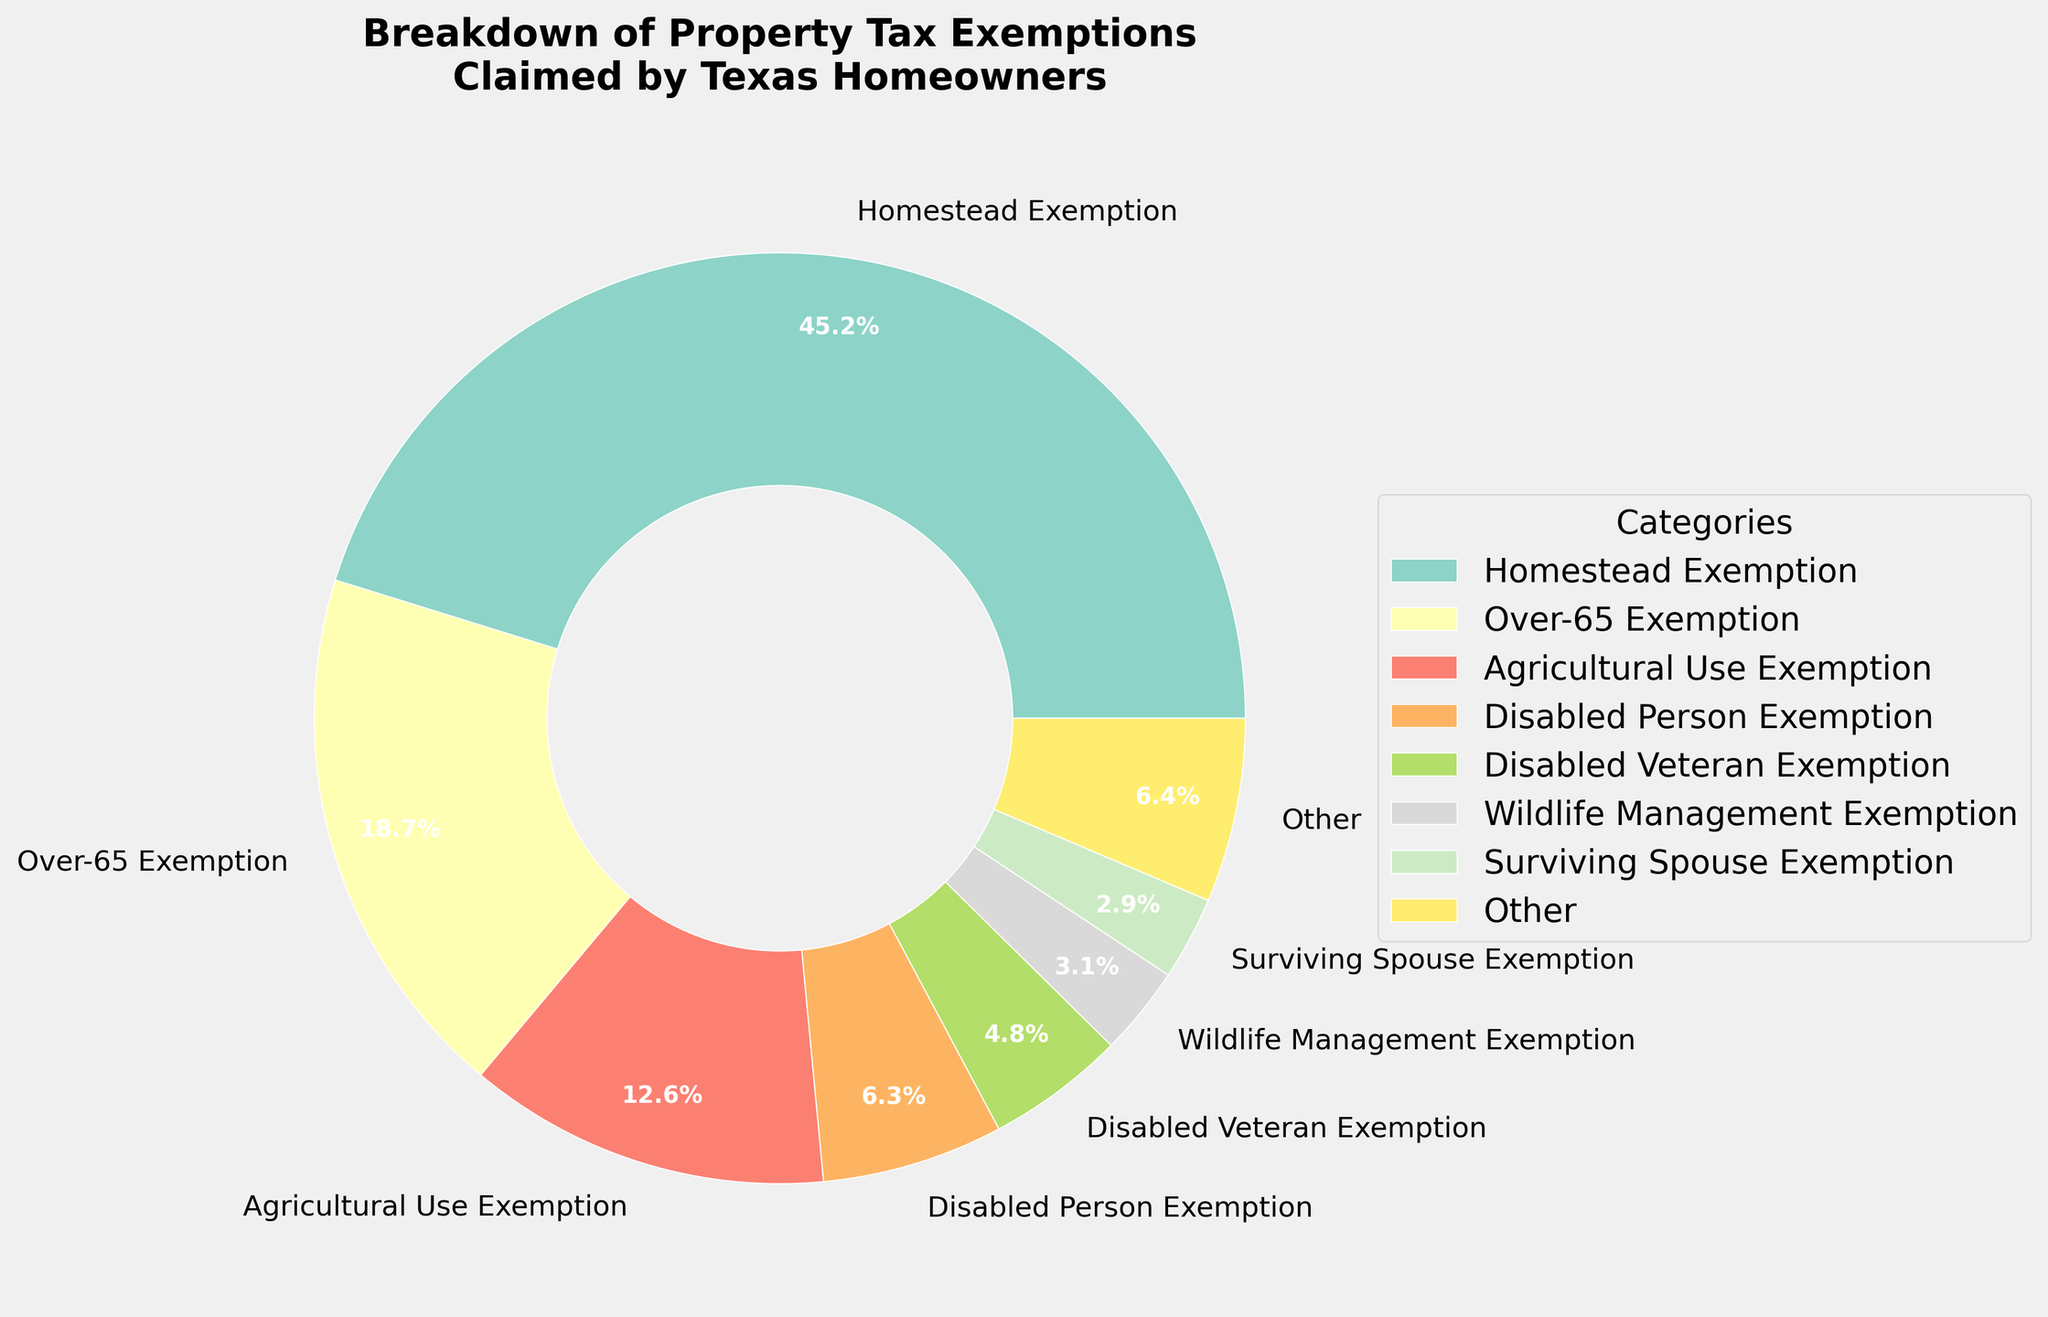Which property tax exemption category has the highest percentage? To determine which category has the highest percentage, look at the segments of the pie chart and their labels. The largest segment will indicate the highest percentage.
Answer: Homestead Exemption How much greater is the percentage of the Homestead Exemption compared to the Over-65 Exemption? First, find the percentages of the Homestead Exemption and the Over-65 Exemption. Subtract the Over-65 Exemption percentage from the Homestead Exemption percentage (45.2 - 18.7).
Answer: 26.5 What are the combined percentages of the Agricultural Use Exemption and Wildlife Management Exemption? Add the percentages of the Agricultural Use Exemption and Wildlife Management Exemption (12.6 + 3.1).
Answer: 15.7 Which exemption category accounts for less than 1% of the total exemptions? Look at the smallest segments of the pie chart and their labels, and identify any segment that has a percentage less than 1%.
Answer: Wind-Powered Energy Device Exemption How many categories are grouped into the 'Other' section, and what is their combined percentage? Identify the number of segments not listed as 'Other' and find the segment labeled 'Other'. The remaining categories not in top 8 are grouped into 'Other', and its percentage is shown on the pie chart.
Answer: 6 categories, 6.2% What percentage of the total exemptions is accounted for by the Disabled Person Exemption and Disabled Veteran Exemption combined? Add the percentages of the Disabled Person Exemption and Disabled Veteran Exemption (6.3 + 4.8).
Answer: 11.1 Which exemption category has a visual segment slightly larger than the Charitable Organization Exemption? Compare the size of the pie segments. Identify the segment that is visually slightly larger than the segment labeled Charitable Organization Exemption.
Answer: Over-65 Exemption How does the percentage of the Solar Energy Device Exemption compare to the Freeport Exemption? Find the percentages for the Solar Energy Device Exemption and the Freeport Exemption, then compare them directly (1.5 vs. 1.2).
Answer: Solar Energy Device Exemption is higher If you combine the percentages of all energy-related exemptions (Solar, Wind-Powered) together, what is the total percentage? Add the percentages of Solar Energy Device Exemption and Wind-Powered Energy Device Exemption (1.5 + 0.8).
Answer: 2.3 What category makes up a smaller percentage than the Wildlife Management Exemption but larger than Pollution Control Exemption? Look for the segment that falls in between the percentages of Wildlife Management Exemption (3.1) and Pollution Control Exemption (0.6).
Answer: Freeport Exemption 